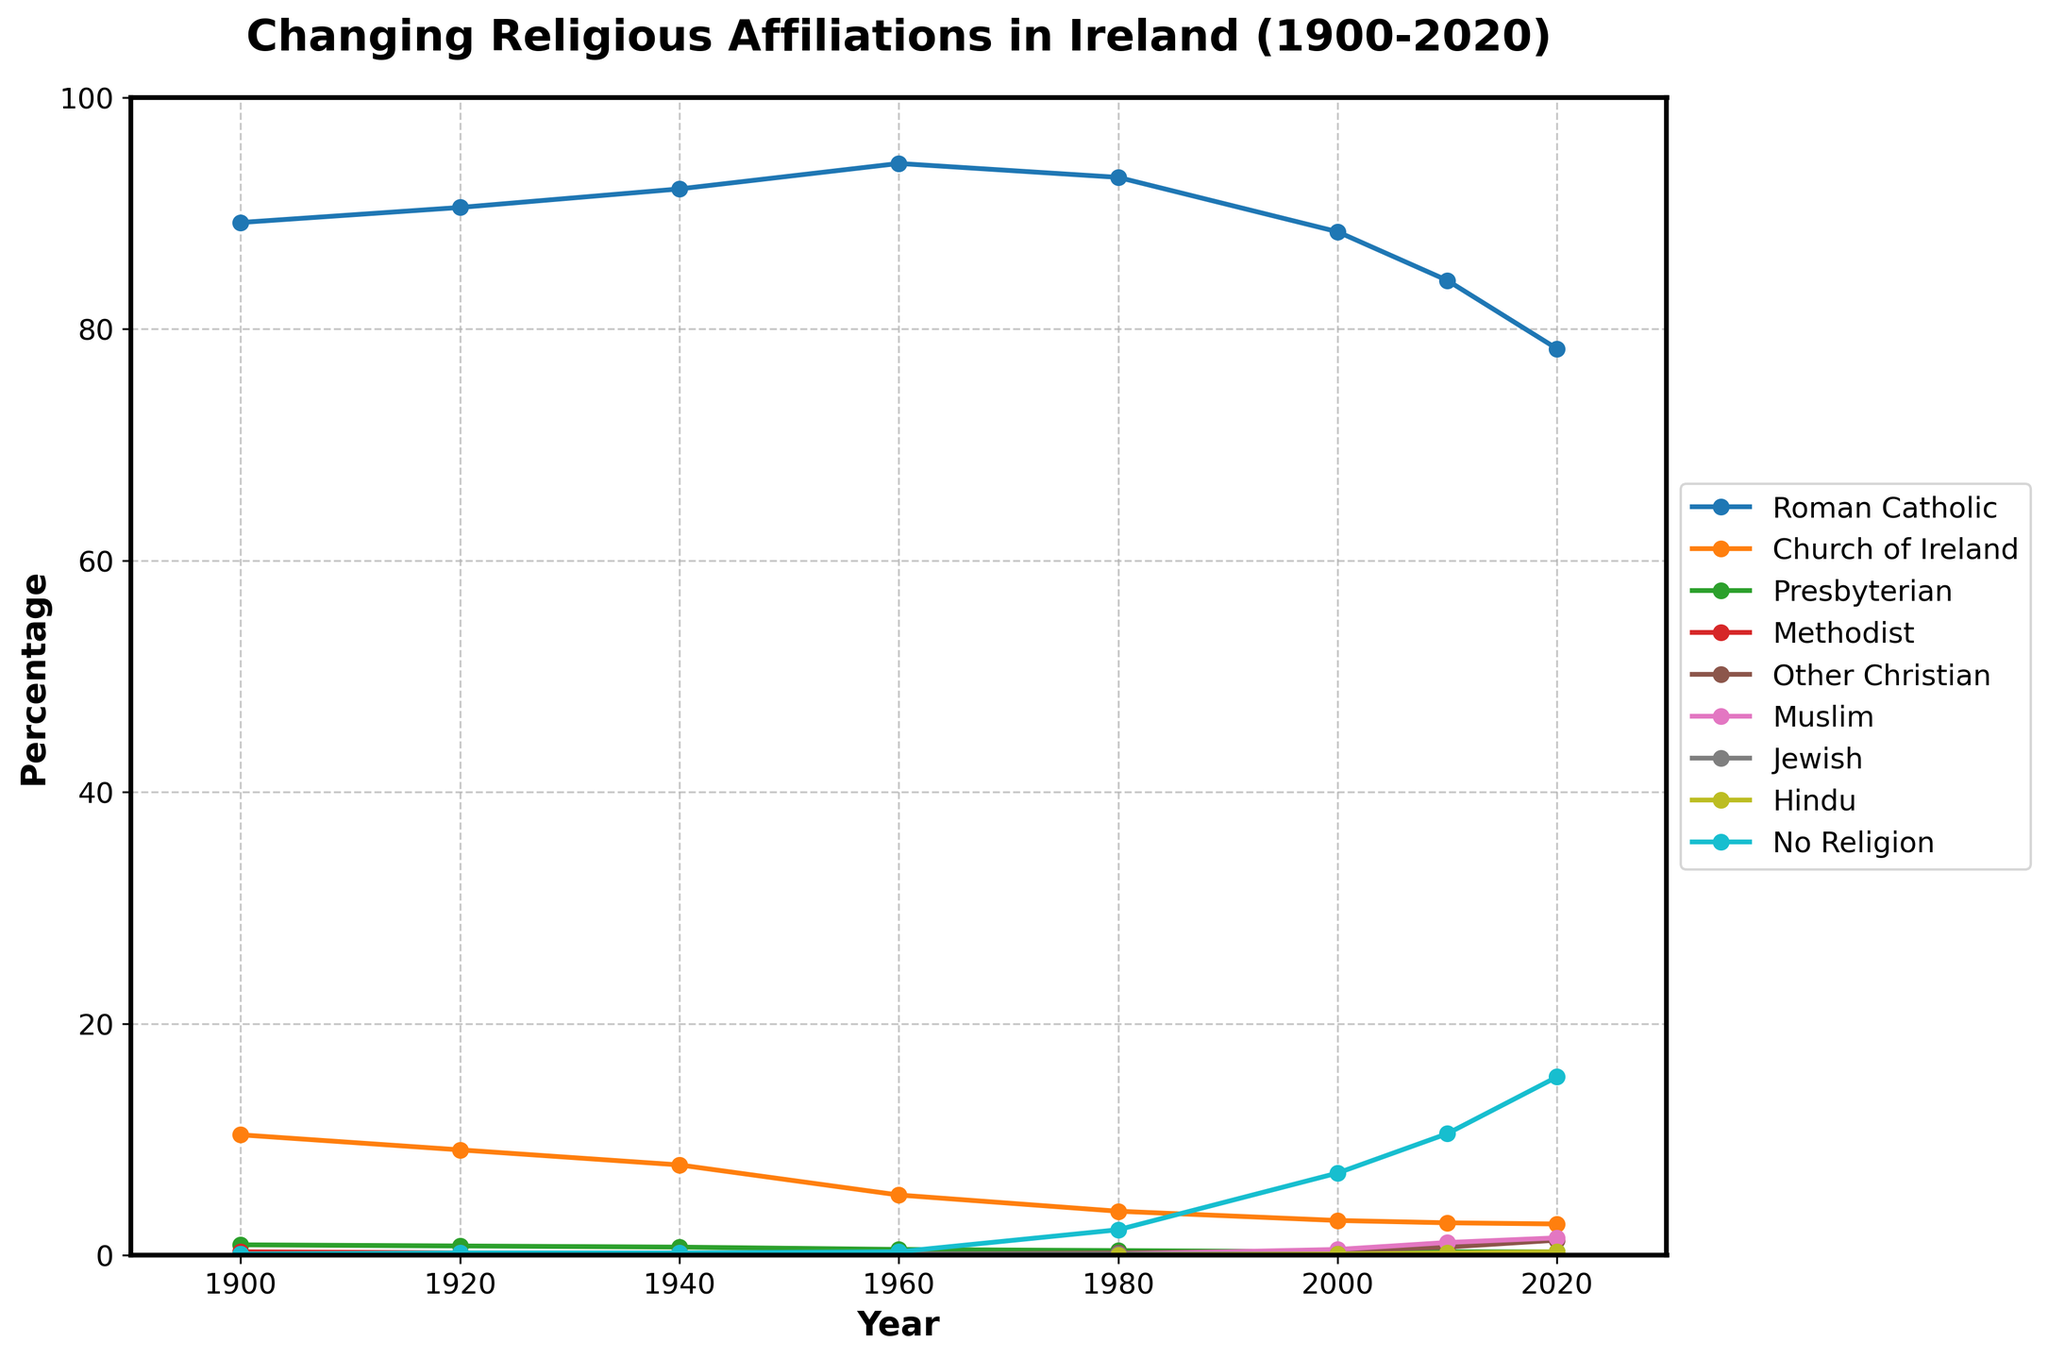What is the trend in the Roman Catholic population from 1900 to 2020? The trend can be observed by following the line representing the Roman Catholic population in the figure. Starting from around 89.2% in 1900, it increases to a peak of 94.3% in 1960 and then gradually declines to 78.3% in 2020.
Answer: Initially rising, then declining Which religious group shows a marked increase in affiliation between 2000 and 2020? By comparing the lines for each religious group between 2000 and 2020, the "No Religion" category shows a significant increase from 7.1% to 15.4%.
Answer: No Religion How has the Muslim population changed from 1980 to 2020? Looking at the figure, the line for the Muslim population starts at 0.1% in 1980 and steadily rises to 1.5% by 2020.
Answer: Increased from 0.1% to 1.5% Between which decades did the Church of Ireland show the greatest decline? Observing the Church of Ireland line, the most significant drop occurs between 1960 and 1980, from 5.2% to 3.8%.
Answer: 1960 to 1980 How does the percentage of Methodists in 1960 compare to that in 2020? The line for the Methodist population shows it was at 0.1% in both 1960 and 2020.
Answer: Equal What is the composite percentage of Other Christian and No Religion in 2020? Adding the values for Other Christian (1.3%) and No Religion (15.4%) in 2020 gives 1.3 + 15.4 = 16.7%.
Answer: 16.7% Which group had the highest affiliation percentage in 2000, and what was it? The figure indicates that Roman Catholic had the highest affiliation in 2000 at 88.4%.
Answer: Roman Catholic, 88.4% What visual cue suggests the most diversity in religious affiliations in 2020? The figure's visual cue showing the most spread out lines with different slopes and colors indicates diverse religious affiliations in 2020, with no single group overwhelmingly dominating.
Answer: Spread out lines Is there any religious group that remained relatively unchanged from 1900 to 2020? The lines corresponding to Jewish and Hindu populations show no significant changes, remaining relatively flat at around 0.1%-0.3%.
Answer: Jewish and Hindu Which year did the Roman Catholic population peak, and what was the value? By observing the peak point of the Roman Catholic line, it is in 1960 with a value of 94.3%.
Answer: 1960, 94.3% 